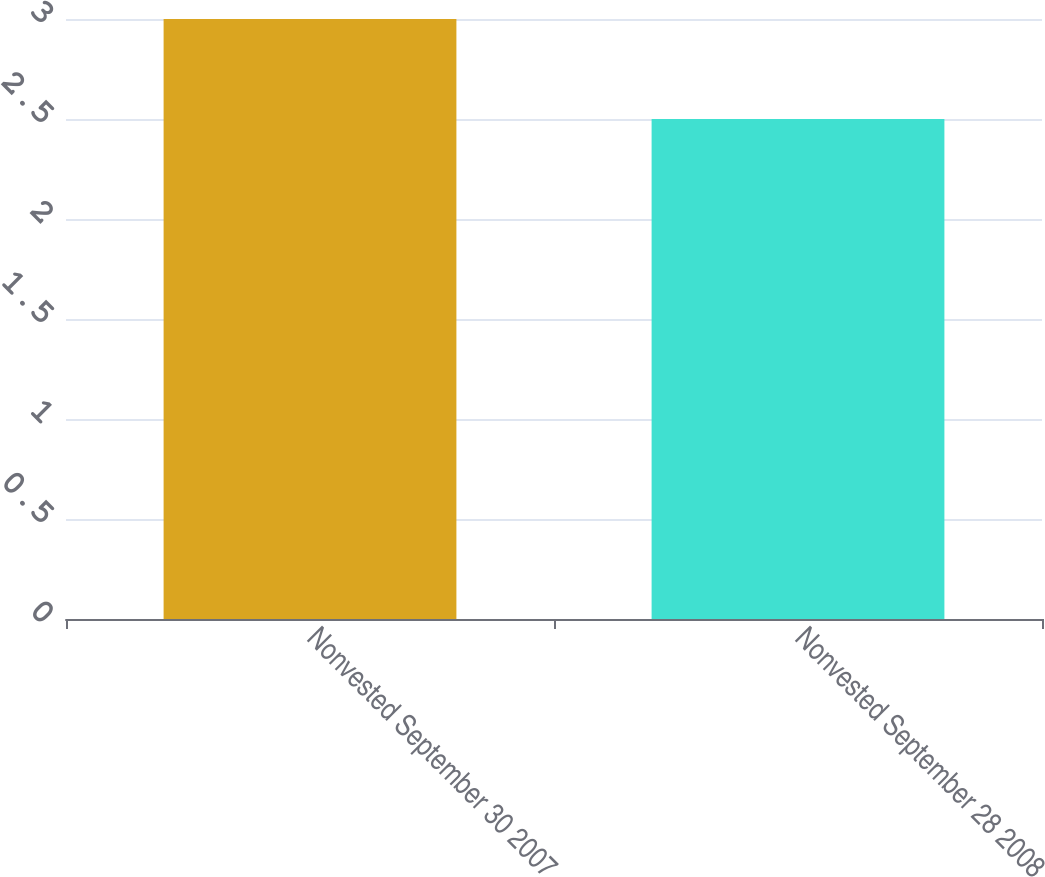<chart> <loc_0><loc_0><loc_500><loc_500><bar_chart><fcel>Nonvested September 30 2007<fcel>Nonvested September 28 2008<nl><fcel>3<fcel>2.5<nl></chart> 